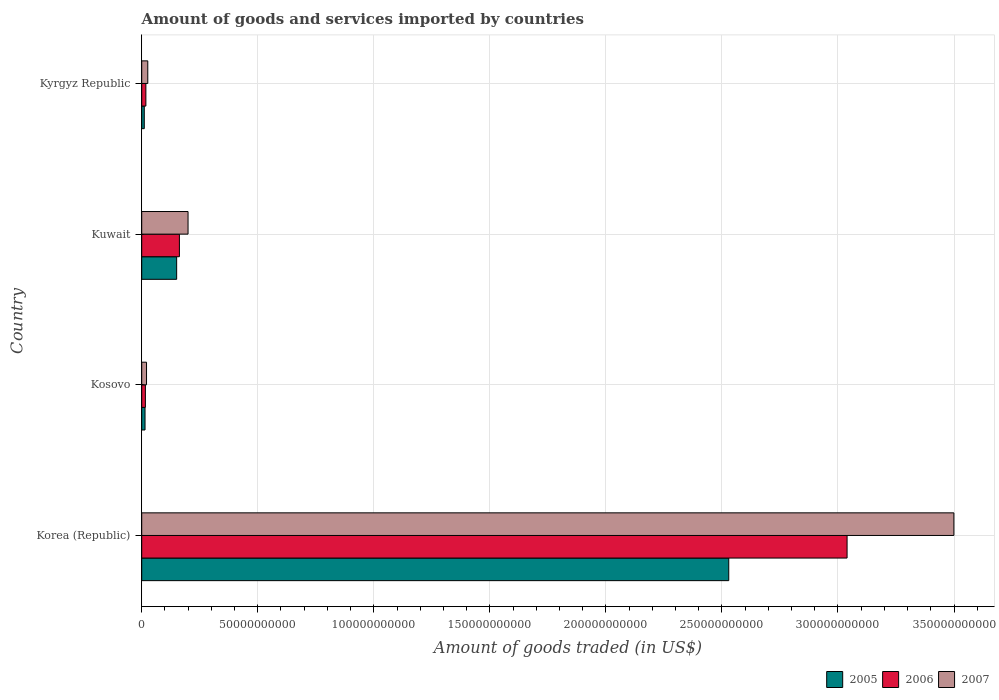How many different coloured bars are there?
Your answer should be very brief. 3. How many groups of bars are there?
Provide a succinct answer. 4. Are the number of bars on each tick of the Y-axis equal?
Your answer should be compact. Yes. How many bars are there on the 4th tick from the bottom?
Ensure brevity in your answer.  3. What is the label of the 1st group of bars from the top?
Keep it short and to the point. Kyrgyz Republic. In how many cases, is the number of bars for a given country not equal to the number of legend labels?
Your answer should be compact. 0. What is the total amount of goods and services imported in 2006 in Kyrgyz Republic?
Offer a terse response. 1.79e+09. Across all countries, what is the maximum total amount of goods and services imported in 2005?
Provide a short and direct response. 2.53e+11. Across all countries, what is the minimum total amount of goods and services imported in 2006?
Ensure brevity in your answer.  1.58e+09. In which country was the total amount of goods and services imported in 2006 maximum?
Offer a terse response. Korea (Republic). In which country was the total amount of goods and services imported in 2007 minimum?
Your response must be concise. Kosovo. What is the total total amount of goods and services imported in 2005 in the graph?
Make the answer very short. 2.71e+11. What is the difference between the total amount of goods and services imported in 2006 in Korea (Republic) and that in Kosovo?
Keep it short and to the point. 3.02e+11. What is the difference between the total amount of goods and services imported in 2006 in Kosovo and the total amount of goods and services imported in 2005 in Korea (Republic)?
Keep it short and to the point. -2.51e+11. What is the average total amount of goods and services imported in 2006 per country?
Make the answer very short. 8.09e+1. What is the difference between the total amount of goods and services imported in 2005 and total amount of goods and services imported in 2007 in Kosovo?
Provide a succinct answer. -6.53e+08. In how many countries, is the total amount of goods and services imported in 2007 greater than 230000000000 US$?
Provide a succinct answer. 1. What is the ratio of the total amount of goods and services imported in 2006 in Korea (Republic) to that in Kyrgyz Republic?
Your response must be concise. 169.56. Is the difference between the total amount of goods and services imported in 2005 in Kosovo and Kuwait greater than the difference between the total amount of goods and services imported in 2007 in Kosovo and Kuwait?
Your answer should be very brief. Yes. What is the difference between the highest and the second highest total amount of goods and services imported in 2007?
Keep it short and to the point. 3.30e+11. What is the difference between the highest and the lowest total amount of goods and services imported in 2006?
Keep it short and to the point. 3.02e+11. What does the 1st bar from the top in Korea (Republic) represents?
Offer a very short reply. 2007. What does the 1st bar from the bottom in Korea (Republic) represents?
Give a very brief answer. 2005. Are all the bars in the graph horizontal?
Your response must be concise. Yes. How many countries are there in the graph?
Offer a very short reply. 4. What is the difference between two consecutive major ticks on the X-axis?
Provide a short and direct response. 5.00e+1. Are the values on the major ticks of X-axis written in scientific E-notation?
Provide a short and direct response. No. Does the graph contain grids?
Provide a short and direct response. Yes. What is the title of the graph?
Your answer should be very brief. Amount of goods and services imported by countries. What is the label or title of the X-axis?
Ensure brevity in your answer.  Amount of goods traded (in US$). What is the Amount of goods traded (in US$) in 2005 in Korea (Republic)?
Give a very brief answer. 2.53e+11. What is the Amount of goods traded (in US$) of 2006 in Korea (Republic)?
Keep it short and to the point. 3.04e+11. What is the Amount of goods traded (in US$) in 2007 in Korea (Republic)?
Your answer should be compact. 3.50e+11. What is the Amount of goods traded (in US$) in 2005 in Kosovo?
Offer a terse response. 1.42e+09. What is the Amount of goods traded (in US$) in 2006 in Kosovo?
Offer a terse response. 1.58e+09. What is the Amount of goods traded (in US$) in 2007 in Kosovo?
Your answer should be very brief. 2.08e+09. What is the Amount of goods traded (in US$) in 2005 in Kuwait?
Ensure brevity in your answer.  1.51e+1. What is the Amount of goods traded (in US$) of 2006 in Kuwait?
Offer a terse response. 1.62e+1. What is the Amount of goods traded (in US$) in 2007 in Kuwait?
Your answer should be compact. 2.00e+1. What is the Amount of goods traded (in US$) in 2005 in Kyrgyz Republic?
Offer a terse response. 1.11e+09. What is the Amount of goods traded (in US$) of 2006 in Kyrgyz Republic?
Offer a terse response. 1.79e+09. What is the Amount of goods traded (in US$) in 2007 in Kyrgyz Republic?
Give a very brief answer. 2.61e+09. Across all countries, what is the maximum Amount of goods traded (in US$) of 2005?
Provide a short and direct response. 2.53e+11. Across all countries, what is the maximum Amount of goods traded (in US$) in 2006?
Give a very brief answer. 3.04e+11. Across all countries, what is the maximum Amount of goods traded (in US$) in 2007?
Your answer should be very brief. 3.50e+11. Across all countries, what is the minimum Amount of goods traded (in US$) in 2005?
Keep it short and to the point. 1.11e+09. Across all countries, what is the minimum Amount of goods traded (in US$) in 2006?
Your response must be concise. 1.58e+09. Across all countries, what is the minimum Amount of goods traded (in US$) of 2007?
Provide a succinct answer. 2.08e+09. What is the total Amount of goods traded (in US$) in 2005 in the graph?
Offer a very short reply. 2.71e+11. What is the total Amount of goods traded (in US$) of 2006 in the graph?
Provide a succinct answer. 3.24e+11. What is the total Amount of goods traded (in US$) of 2007 in the graph?
Make the answer very short. 3.75e+11. What is the difference between the Amount of goods traded (in US$) in 2005 in Korea (Republic) and that in Kosovo?
Offer a very short reply. 2.52e+11. What is the difference between the Amount of goods traded (in US$) of 2006 in Korea (Republic) and that in Kosovo?
Your response must be concise. 3.02e+11. What is the difference between the Amount of goods traded (in US$) in 2007 in Korea (Republic) and that in Kosovo?
Provide a short and direct response. 3.48e+11. What is the difference between the Amount of goods traded (in US$) of 2005 in Korea (Republic) and that in Kuwait?
Provide a short and direct response. 2.38e+11. What is the difference between the Amount of goods traded (in US$) in 2006 in Korea (Republic) and that in Kuwait?
Your answer should be very brief. 2.88e+11. What is the difference between the Amount of goods traded (in US$) in 2007 in Korea (Republic) and that in Kuwait?
Your answer should be very brief. 3.30e+11. What is the difference between the Amount of goods traded (in US$) of 2005 in Korea (Republic) and that in Kyrgyz Republic?
Offer a terse response. 2.52e+11. What is the difference between the Amount of goods traded (in US$) of 2006 in Korea (Republic) and that in Kyrgyz Republic?
Provide a succinct answer. 3.02e+11. What is the difference between the Amount of goods traded (in US$) in 2007 in Korea (Republic) and that in Kyrgyz Republic?
Provide a succinct answer. 3.47e+11. What is the difference between the Amount of goods traded (in US$) in 2005 in Kosovo and that in Kuwait?
Make the answer very short. -1.36e+1. What is the difference between the Amount of goods traded (in US$) in 2006 in Kosovo and that in Kuwait?
Provide a succinct answer. -1.47e+1. What is the difference between the Amount of goods traded (in US$) in 2007 in Kosovo and that in Kuwait?
Provide a short and direct response. -1.79e+1. What is the difference between the Amount of goods traded (in US$) in 2005 in Kosovo and that in Kyrgyz Republic?
Ensure brevity in your answer.  3.17e+08. What is the difference between the Amount of goods traded (in US$) in 2006 in Kosovo and that in Kyrgyz Republic?
Your answer should be very brief. -2.09e+08. What is the difference between the Amount of goods traded (in US$) of 2007 in Kosovo and that in Kyrgyz Republic?
Provide a succinct answer. -5.38e+08. What is the difference between the Amount of goods traded (in US$) in 2005 in Kuwait and that in Kyrgyz Republic?
Make the answer very short. 1.39e+1. What is the difference between the Amount of goods traded (in US$) in 2006 in Kuwait and that in Kyrgyz Republic?
Provide a succinct answer. 1.44e+1. What is the difference between the Amount of goods traded (in US$) in 2007 in Kuwait and that in Kyrgyz Republic?
Offer a terse response. 1.73e+1. What is the difference between the Amount of goods traded (in US$) of 2005 in Korea (Republic) and the Amount of goods traded (in US$) of 2006 in Kosovo?
Keep it short and to the point. 2.51e+11. What is the difference between the Amount of goods traded (in US$) in 2005 in Korea (Republic) and the Amount of goods traded (in US$) in 2007 in Kosovo?
Give a very brief answer. 2.51e+11. What is the difference between the Amount of goods traded (in US$) of 2006 in Korea (Republic) and the Amount of goods traded (in US$) of 2007 in Kosovo?
Offer a very short reply. 3.02e+11. What is the difference between the Amount of goods traded (in US$) in 2005 in Korea (Republic) and the Amount of goods traded (in US$) in 2006 in Kuwait?
Provide a short and direct response. 2.37e+11. What is the difference between the Amount of goods traded (in US$) of 2005 in Korea (Republic) and the Amount of goods traded (in US$) of 2007 in Kuwait?
Your response must be concise. 2.33e+11. What is the difference between the Amount of goods traded (in US$) of 2006 in Korea (Republic) and the Amount of goods traded (in US$) of 2007 in Kuwait?
Your answer should be very brief. 2.84e+11. What is the difference between the Amount of goods traded (in US$) in 2005 in Korea (Republic) and the Amount of goods traded (in US$) in 2006 in Kyrgyz Republic?
Make the answer very short. 2.51e+11. What is the difference between the Amount of goods traded (in US$) in 2005 in Korea (Republic) and the Amount of goods traded (in US$) in 2007 in Kyrgyz Republic?
Your response must be concise. 2.50e+11. What is the difference between the Amount of goods traded (in US$) in 2006 in Korea (Republic) and the Amount of goods traded (in US$) in 2007 in Kyrgyz Republic?
Your response must be concise. 3.01e+11. What is the difference between the Amount of goods traded (in US$) in 2005 in Kosovo and the Amount of goods traded (in US$) in 2006 in Kuwait?
Provide a succinct answer. -1.48e+1. What is the difference between the Amount of goods traded (in US$) of 2005 in Kosovo and the Amount of goods traded (in US$) of 2007 in Kuwait?
Offer a very short reply. -1.85e+1. What is the difference between the Amount of goods traded (in US$) in 2006 in Kosovo and the Amount of goods traded (in US$) in 2007 in Kuwait?
Keep it short and to the point. -1.84e+1. What is the difference between the Amount of goods traded (in US$) in 2005 in Kosovo and the Amount of goods traded (in US$) in 2006 in Kyrgyz Republic?
Ensure brevity in your answer.  -3.70e+08. What is the difference between the Amount of goods traded (in US$) of 2005 in Kosovo and the Amount of goods traded (in US$) of 2007 in Kyrgyz Republic?
Make the answer very short. -1.19e+09. What is the difference between the Amount of goods traded (in US$) of 2006 in Kosovo and the Amount of goods traded (in US$) of 2007 in Kyrgyz Republic?
Keep it short and to the point. -1.03e+09. What is the difference between the Amount of goods traded (in US$) in 2005 in Kuwait and the Amount of goods traded (in US$) in 2006 in Kyrgyz Republic?
Keep it short and to the point. 1.33e+1. What is the difference between the Amount of goods traded (in US$) of 2005 in Kuwait and the Amount of goods traded (in US$) of 2007 in Kyrgyz Republic?
Make the answer very short. 1.24e+1. What is the difference between the Amount of goods traded (in US$) in 2006 in Kuwait and the Amount of goods traded (in US$) in 2007 in Kyrgyz Republic?
Your answer should be very brief. 1.36e+1. What is the average Amount of goods traded (in US$) of 2005 per country?
Your response must be concise. 6.76e+1. What is the average Amount of goods traded (in US$) in 2006 per country?
Your answer should be compact. 8.09e+1. What is the average Amount of goods traded (in US$) of 2007 per country?
Ensure brevity in your answer.  9.37e+1. What is the difference between the Amount of goods traded (in US$) of 2005 and Amount of goods traded (in US$) of 2006 in Korea (Republic)?
Offer a very short reply. -5.10e+1. What is the difference between the Amount of goods traded (in US$) in 2005 and Amount of goods traded (in US$) in 2007 in Korea (Republic)?
Ensure brevity in your answer.  -9.70e+1. What is the difference between the Amount of goods traded (in US$) of 2006 and Amount of goods traded (in US$) of 2007 in Korea (Republic)?
Provide a short and direct response. -4.60e+1. What is the difference between the Amount of goods traded (in US$) in 2005 and Amount of goods traded (in US$) in 2006 in Kosovo?
Give a very brief answer. -1.61e+08. What is the difference between the Amount of goods traded (in US$) of 2005 and Amount of goods traded (in US$) of 2007 in Kosovo?
Offer a terse response. -6.53e+08. What is the difference between the Amount of goods traded (in US$) in 2006 and Amount of goods traded (in US$) in 2007 in Kosovo?
Provide a succinct answer. -4.92e+08. What is the difference between the Amount of goods traded (in US$) of 2005 and Amount of goods traded (in US$) of 2006 in Kuwait?
Ensure brevity in your answer.  -1.19e+09. What is the difference between the Amount of goods traded (in US$) in 2005 and Amount of goods traded (in US$) in 2007 in Kuwait?
Give a very brief answer. -4.91e+09. What is the difference between the Amount of goods traded (in US$) in 2006 and Amount of goods traded (in US$) in 2007 in Kuwait?
Provide a succinct answer. -3.72e+09. What is the difference between the Amount of goods traded (in US$) of 2005 and Amount of goods traded (in US$) of 2006 in Kyrgyz Republic?
Ensure brevity in your answer.  -6.87e+08. What is the difference between the Amount of goods traded (in US$) in 2005 and Amount of goods traded (in US$) in 2007 in Kyrgyz Republic?
Offer a very short reply. -1.51e+09. What is the difference between the Amount of goods traded (in US$) in 2006 and Amount of goods traded (in US$) in 2007 in Kyrgyz Republic?
Provide a succinct answer. -8.21e+08. What is the ratio of the Amount of goods traded (in US$) in 2005 in Korea (Republic) to that in Kosovo?
Make the answer very short. 177.79. What is the ratio of the Amount of goods traded (in US$) of 2006 in Korea (Republic) to that in Kosovo?
Ensure brevity in your answer.  191.94. What is the ratio of the Amount of goods traded (in US$) of 2007 in Korea (Republic) to that in Kosovo?
Provide a succinct answer. 168.62. What is the ratio of the Amount of goods traded (in US$) of 2005 in Korea (Republic) to that in Kuwait?
Your answer should be very brief. 16.8. What is the ratio of the Amount of goods traded (in US$) in 2006 in Korea (Republic) to that in Kuwait?
Ensure brevity in your answer.  18.71. What is the ratio of the Amount of goods traded (in US$) in 2007 in Korea (Republic) to that in Kuwait?
Give a very brief answer. 17.53. What is the ratio of the Amount of goods traded (in US$) of 2005 in Korea (Republic) to that in Kyrgyz Republic?
Make the answer very short. 228.79. What is the ratio of the Amount of goods traded (in US$) of 2006 in Korea (Republic) to that in Kyrgyz Republic?
Offer a terse response. 169.56. What is the ratio of the Amount of goods traded (in US$) in 2007 in Korea (Republic) to that in Kyrgyz Republic?
Give a very brief answer. 133.9. What is the ratio of the Amount of goods traded (in US$) of 2005 in Kosovo to that in Kuwait?
Your answer should be very brief. 0.09. What is the ratio of the Amount of goods traded (in US$) of 2006 in Kosovo to that in Kuwait?
Keep it short and to the point. 0.1. What is the ratio of the Amount of goods traded (in US$) in 2007 in Kosovo to that in Kuwait?
Your answer should be very brief. 0.1. What is the ratio of the Amount of goods traded (in US$) of 2005 in Kosovo to that in Kyrgyz Republic?
Make the answer very short. 1.29. What is the ratio of the Amount of goods traded (in US$) in 2006 in Kosovo to that in Kyrgyz Republic?
Your answer should be compact. 0.88. What is the ratio of the Amount of goods traded (in US$) in 2007 in Kosovo to that in Kyrgyz Republic?
Offer a very short reply. 0.79. What is the ratio of the Amount of goods traded (in US$) of 2005 in Kuwait to that in Kyrgyz Republic?
Your response must be concise. 13.62. What is the ratio of the Amount of goods traded (in US$) in 2006 in Kuwait to that in Kyrgyz Republic?
Make the answer very short. 9.06. What is the ratio of the Amount of goods traded (in US$) in 2007 in Kuwait to that in Kyrgyz Republic?
Offer a very short reply. 7.64. What is the difference between the highest and the second highest Amount of goods traded (in US$) in 2005?
Ensure brevity in your answer.  2.38e+11. What is the difference between the highest and the second highest Amount of goods traded (in US$) of 2006?
Your answer should be compact. 2.88e+11. What is the difference between the highest and the second highest Amount of goods traded (in US$) in 2007?
Make the answer very short. 3.30e+11. What is the difference between the highest and the lowest Amount of goods traded (in US$) in 2005?
Give a very brief answer. 2.52e+11. What is the difference between the highest and the lowest Amount of goods traded (in US$) of 2006?
Provide a short and direct response. 3.02e+11. What is the difference between the highest and the lowest Amount of goods traded (in US$) in 2007?
Ensure brevity in your answer.  3.48e+11. 